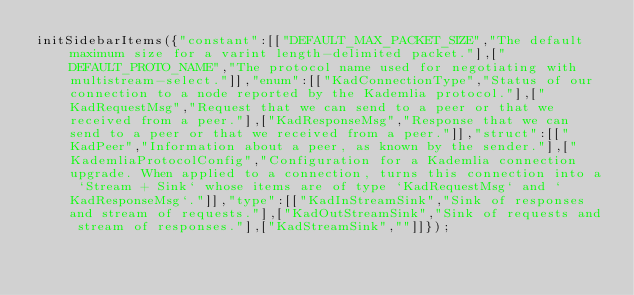<code> <loc_0><loc_0><loc_500><loc_500><_JavaScript_>initSidebarItems({"constant":[["DEFAULT_MAX_PACKET_SIZE","The default maximum size for a varint length-delimited packet."],["DEFAULT_PROTO_NAME","The protocol name used for negotiating with multistream-select."]],"enum":[["KadConnectionType","Status of our connection to a node reported by the Kademlia protocol."],["KadRequestMsg","Request that we can send to a peer or that we received from a peer."],["KadResponseMsg","Response that we can send to a peer or that we received from a peer."]],"struct":[["KadPeer","Information about a peer, as known by the sender."],["KademliaProtocolConfig","Configuration for a Kademlia connection upgrade. When applied to a connection, turns this connection into a `Stream + Sink` whose items are of type `KadRequestMsg` and `KadResponseMsg`."]],"type":[["KadInStreamSink","Sink of responses and stream of requests."],["KadOutStreamSink","Sink of requests and stream of responses."],["KadStreamSink",""]]});</code> 